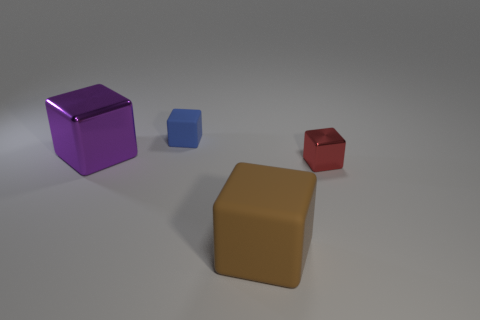What size is the shiny cube on the right side of the big cube behind the tiny cube that is on the right side of the tiny matte object?
Offer a very short reply. Small. Are there any other things of the same color as the tiny matte cube?
Ensure brevity in your answer.  No. There is a tiny cube that is in front of the large thing behind the shiny object on the right side of the large brown matte block; what is its material?
Offer a terse response. Metal. Is the tiny rubber object the same shape as the big purple metal object?
Keep it short and to the point. Yes. Are there any other things that have the same material as the brown object?
Keep it short and to the point. Yes. How many blocks are both in front of the tiny blue block and behind the brown rubber thing?
Give a very brief answer. 2. What is the color of the rubber thing that is to the right of the matte cube that is behind the large shiny thing?
Your response must be concise. Brown. Are there an equal number of red cubes that are right of the red object and big gray metallic objects?
Make the answer very short. Yes. There is a small red shiny cube behind the rubber thing that is in front of the tiny blue rubber object; how many tiny blocks are behind it?
Keep it short and to the point. 1. There is a matte cube that is right of the small blue thing; what color is it?
Offer a very short reply. Brown. 